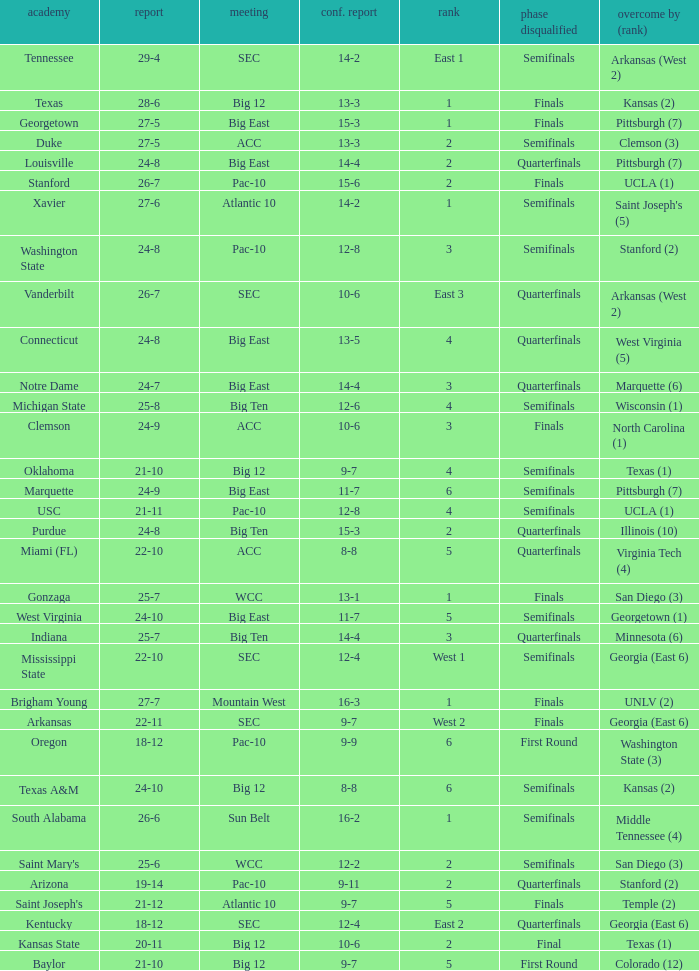Name the conference record where seed is 3 and record is 24-9 10-6. 